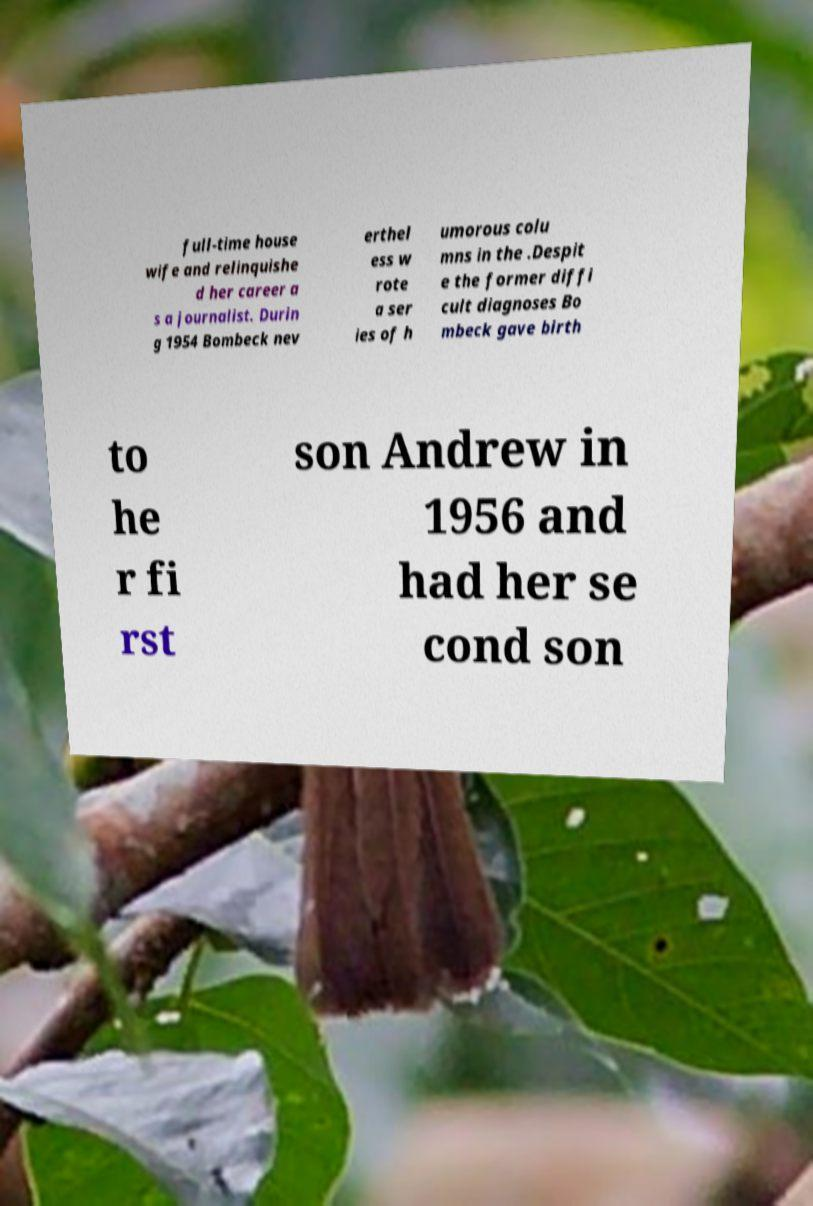I need the written content from this picture converted into text. Can you do that? full-time house wife and relinquishe d her career a s a journalist. Durin g 1954 Bombeck nev erthel ess w rote a ser ies of h umorous colu mns in the .Despit e the former diffi cult diagnoses Bo mbeck gave birth to he r fi rst son Andrew in 1956 and had her se cond son 